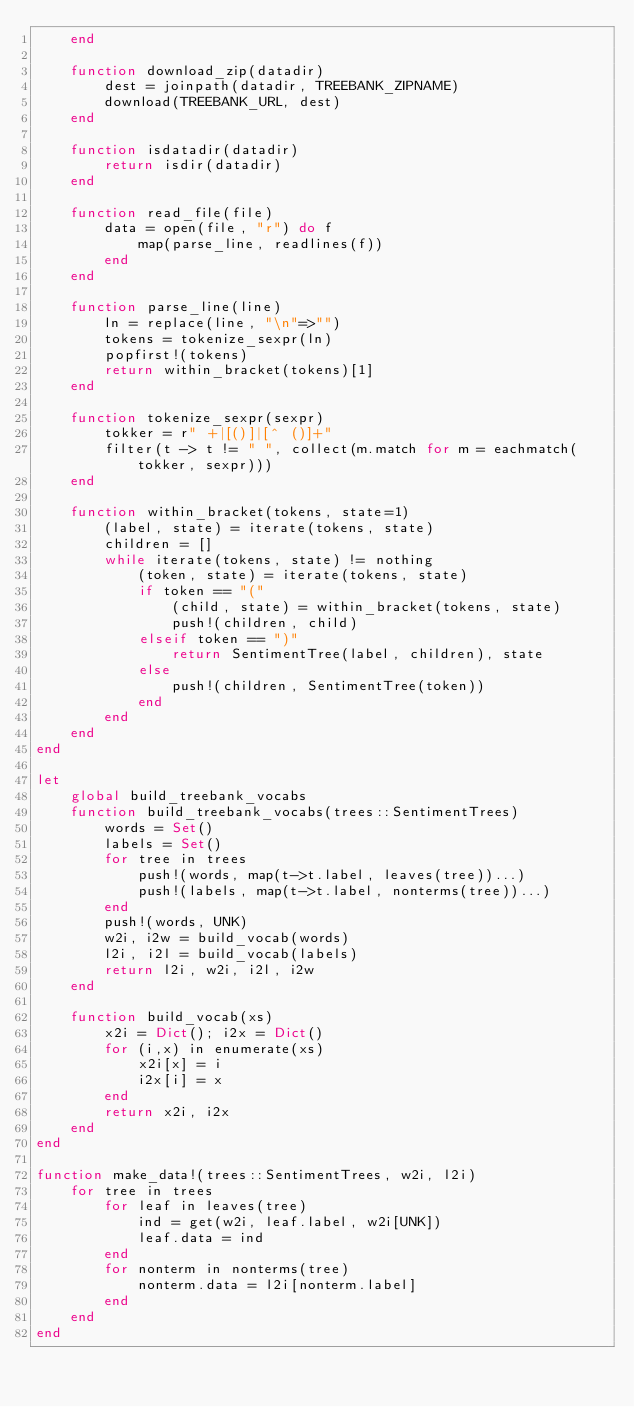Convert code to text. <code><loc_0><loc_0><loc_500><loc_500><_Julia_>    end

    function download_zip(datadir)
        dest = joinpath(datadir, TREEBANK_ZIPNAME)
        download(TREEBANK_URL, dest)
    end

    function isdatadir(datadir)
        return isdir(datadir)
    end

    function read_file(file)
        data = open(file, "r") do f
            map(parse_line, readlines(f))
        end
    end

    function parse_line(line)
        ln = replace(line, "\n"=>"")
        tokens = tokenize_sexpr(ln)
        popfirst!(tokens)
        return within_bracket(tokens)[1]
    end

    function tokenize_sexpr(sexpr)
        tokker = r" +|[()]|[^ ()]+"
        filter(t -> t != " ", collect(m.match for m = eachmatch(tokker, sexpr)))
    end

    function within_bracket(tokens, state=1)
        (label, state) = iterate(tokens, state)
        children = []
        while iterate(tokens, state) != nothing
            (token, state) = iterate(tokens, state)
            if token == "("
                (child, state) = within_bracket(tokens, state)
                push!(children, child)
            elseif token == ")"
                return SentimentTree(label, children), state
            else
                push!(children, SentimentTree(token))
            end
        end
    end
end

let
    global build_treebank_vocabs
    function build_treebank_vocabs(trees::SentimentTrees)
        words = Set()
        labels = Set()
        for tree in trees
            push!(words, map(t->t.label, leaves(tree))...)
            push!(labels, map(t->t.label, nonterms(tree))...)
        end
        push!(words, UNK)
        w2i, i2w = build_vocab(words)
        l2i, i2l = build_vocab(labels)
        return l2i, w2i, i2l, i2w
    end

    function build_vocab(xs)
        x2i = Dict(); i2x = Dict()
        for (i,x) in enumerate(xs)
            x2i[x] = i
            i2x[i] = x
        end
        return x2i, i2x
    end
end

function make_data!(trees::SentimentTrees, w2i, l2i)
    for tree in trees
        for leaf in leaves(tree)
            ind = get(w2i, leaf.label, w2i[UNK])
            leaf.data = ind
        end
        for nonterm in nonterms(tree)
            nonterm.data = l2i[nonterm.label]
        end
    end
end
</code> 